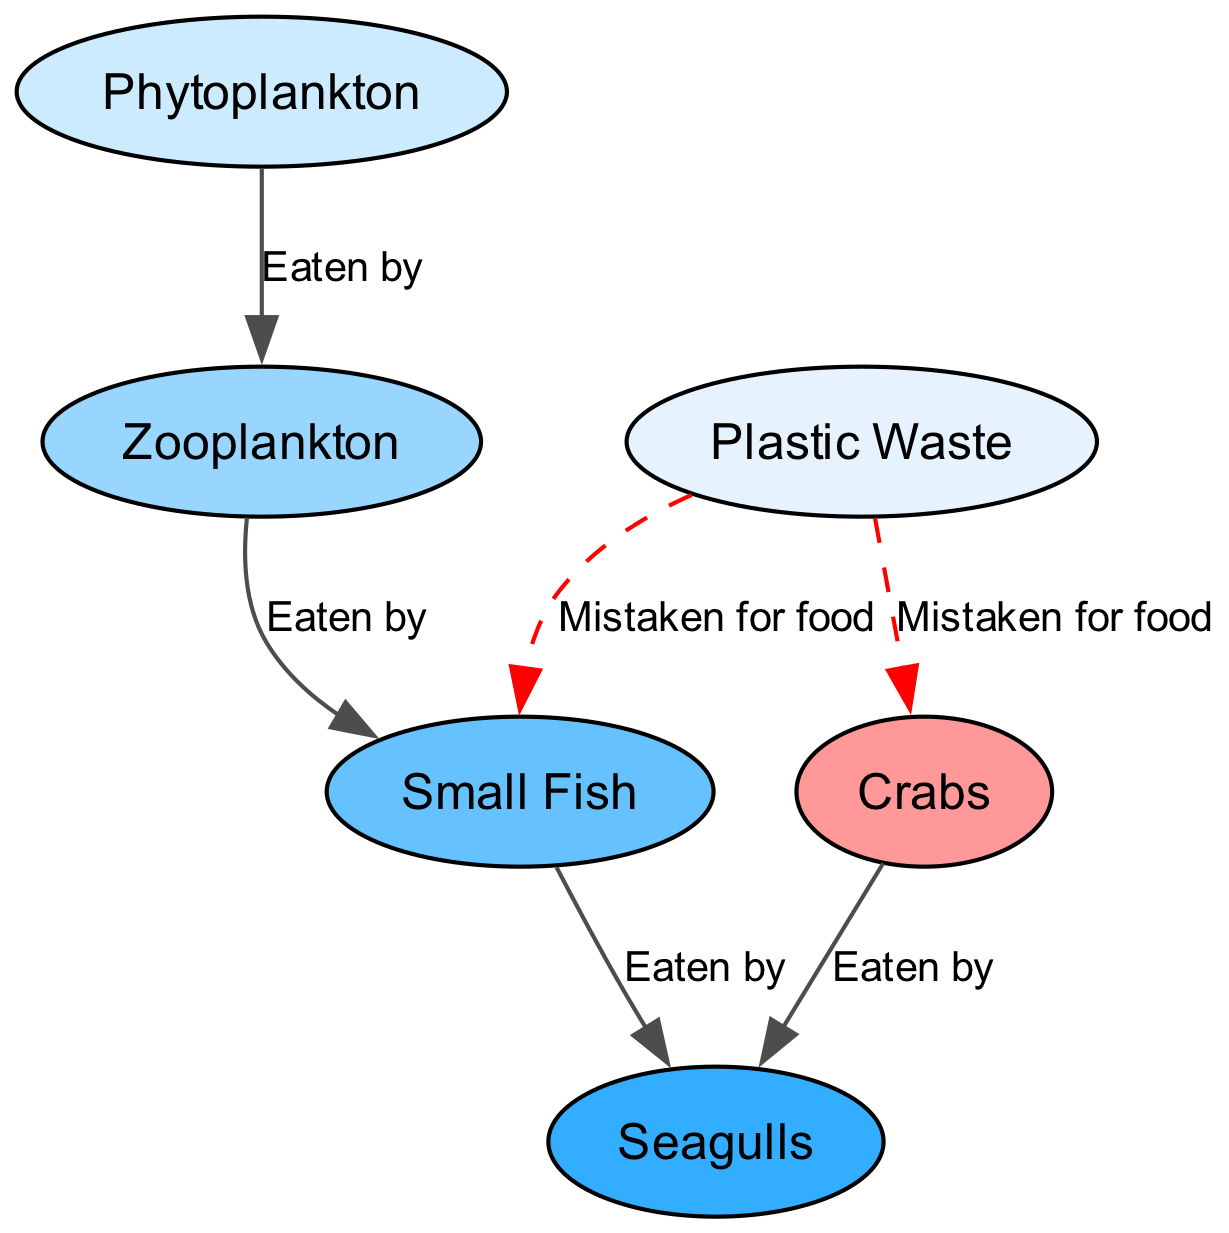What is the starting point of the food chain? The starting point is represented by the first node in the diagram, which is Phytoplankton. It is the producer and forms the base of the marine food chain.
Answer: Phytoplankton How many nodes are in the food chain? The number of nodes can be counted directly from the diagram. There are six nodes: Phytoplankton, Zooplankton, Small Fish, Seagulls, Crabs, and Plastic Waste.
Answer: 6 Which organism eats Zooplankton? The arrow from Zooplankton to Small Fish indicates that Small Fish is the organism that eats Zooplankton, as per the labeling on the edge.
Answer: Small Fish What is the relationship between Small Fish and Seagulls? The edge that connects Small Fish to Seagulls labeled "Eaten by" shows that Seagulls consume Small Fish, establishing a predator-prey relationship.
Answer: Eaten by What type of relationship does Plastic Waste have with Crabs? The edge labeled "Mistaken for food" suggests that Crabs can confuse Plastic Waste for actual food, illustrating a negative impact on marine life.
Answer: Mistaken for food How many organisms are directly eaten by Seagulls? By analyzing the diagram, there are two organisms that are direct prey for Seagulls: Small Fish and Crabs. Thus, the total is two.
Answer: 2 Which node acts as a source of food for both Small Fish and Crabs? The diagram indicates that Phytoplankton is the source of food for Zooplankton, which in turn feeds Small Fish. Additionally, there is a connection where Plastic Waste can also mistakenly be ingested by Crabs.
Answer: Phytoplankton How many distinct types of relationships are shown in the diagram? The diagram displays two types of relationships: "Eaten by" and "Mistaken for food." Therefore, there are two distinct types present in the food chain.
Answer: 2 What effect does Plastic Waste have on the marine food chain? Plastic Waste disrupts the food chain by being mistaken for food by both Small Fish and Crabs, indicating harmful effects on marine organisms' health and survival.
Answer: Harmful effects 